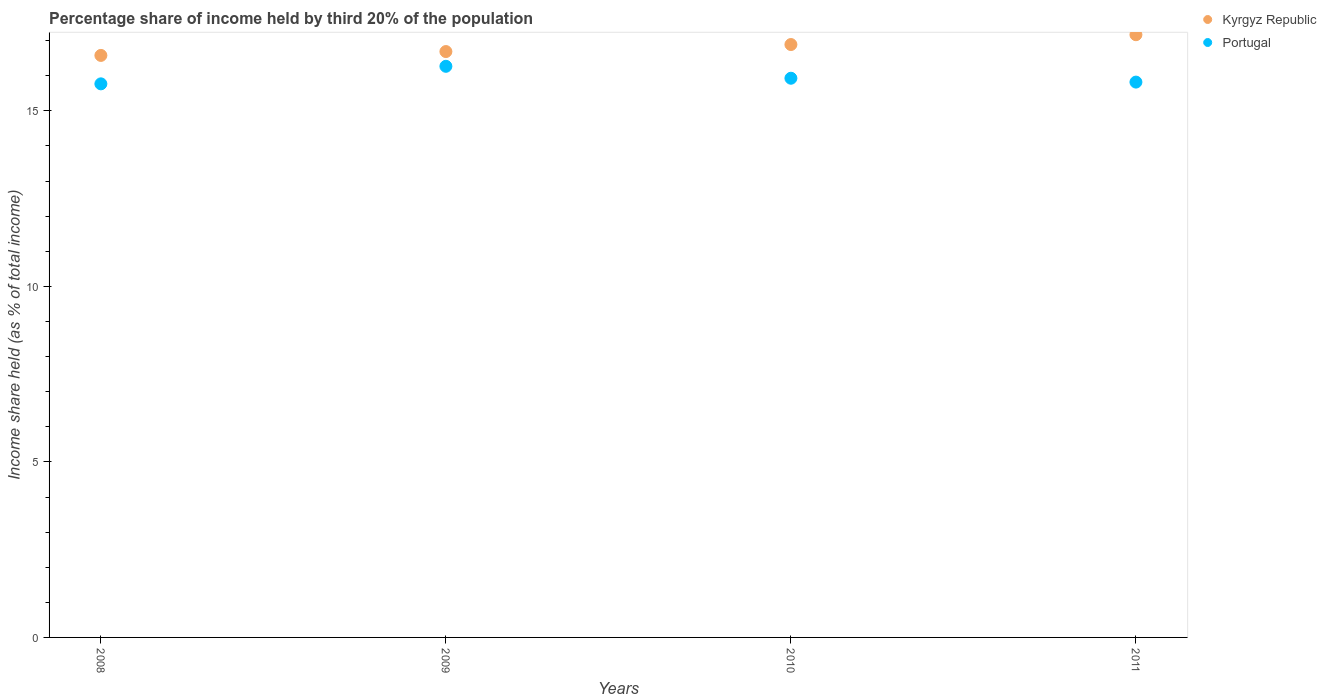How many different coloured dotlines are there?
Ensure brevity in your answer.  2. Is the number of dotlines equal to the number of legend labels?
Ensure brevity in your answer.  Yes. What is the share of income held by third 20% of the population in Kyrgyz Republic in 2009?
Make the answer very short. 16.69. Across all years, what is the maximum share of income held by third 20% of the population in Kyrgyz Republic?
Give a very brief answer. 17.17. Across all years, what is the minimum share of income held by third 20% of the population in Kyrgyz Republic?
Provide a succinct answer. 16.58. In which year was the share of income held by third 20% of the population in Portugal maximum?
Offer a terse response. 2009. What is the total share of income held by third 20% of the population in Portugal in the graph?
Offer a very short reply. 63.79. What is the difference between the share of income held by third 20% of the population in Portugal in 2008 and that in 2011?
Keep it short and to the point. -0.05. What is the difference between the share of income held by third 20% of the population in Portugal in 2010 and the share of income held by third 20% of the population in Kyrgyz Republic in 2009?
Offer a very short reply. -0.76. What is the average share of income held by third 20% of the population in Portugal per year?
Provide a succinct answer. 15.95. In the year 2011, what is the difference between the share of income held by third 20% of the population in Kyrgyz Republic and share of income held by third 20% of the population in Portugal?
Provide a succinct answer. 1.35. What is the ratio of the share of income held by third 20% of the population in Kyrgyz Republic in 2008 to that in 2009?
Provide a short and direct response. 0.99. Is the difference between the share of income held by third 20% of the population in Kyrgyz Republic in 2008 and 2011 greater than the difference between the share of income held by third 20% of the population in Portugal in 2008 and 2011?
Offer a terse response. No. What is the difference between the highest and the second highest share of income held by third 20% of the population in Portugal?
Your answer should be compact. 0.34. What is the difference between the highest and the lowest share of income held by third 20% of the population in Kyrgyz Republic?
Offer a very short reply. 0.59. In how many years, is the share of income held by third 20% of the population in Portugal greater than the average share of income held by third 20% of the population in Portugal taken over all years?
Your response must be concise. 1. Is the sum of the share of income held by third 20% of the population in Portugal in 2009 and 2011 greater than the maximum share of income held by third 20% of the population in Kyrgyz Republic across all years?
Ensure brevity in your answer.  Yes. Does the share of income held by third 20% of the population in Kyrgyz Republic monotonically increase over the years?
Provide a short and direct response. Yes. Is the share of income held by third 20% of the population in Portugal strictly greater than the share of income held by third 20% of the population in Kyrgyz Republic over the years?
Your answer should be very brief. No. Is the share of income held by third 20% of the population in Kyrgyz Republic strictly less than the share of income held by third 20% of the population in Portugal over the years?
Give a very brief answer. No. How many years are there in the graph?
Provide a succinct answer. 4. What is the difference between two consecutive major ticks on the Y-axis?
Give a very brief answer. 5. Does the graph contain any zero values?
Your response must be concise. No. Does the graph contain grids?
Make the answer very short. No. Where does the legend appear in the graph?
Provide a succinct answer. Top right. What is the title of the graph?
Offer a terse response. Percentage share of income held by third 20% of the population. What is the label or title of the X-axis?
Offer a very short reply. Years. What is the label or title of the Y-axis?
Your response must be concise. Income share held (as % of total income). What is the Income share held (as % of total income) of Kyrgyz Republic in 2008?
Ensure brevity in your answer.  16.58. What is the Income share held (as % of total income) of Portugal in 2008?
Your answer should be compact. 15.77. What is the Income share held (as % of total income) in Kyrgyz Republic in 2009?
Provide a short and direct response. 16.69. What is the Income share held (as % of total income) of Portugal in 2009?
Provide a succinct answer. 16.27. What is the Income share held (as % of total income) in Kyrgyz Republic in 2010?
Make the answer very short. 16.89. What is the Income share held (as % of total income) of Portugal in 2010?
Offer a terse response. 15.93. What is the Income share held (as % of total income) of Kyrgyz Republic in 2011?
Provide a succinct answer. 17.17. What is the Income share held (as % of total income) in Portugal in 2011?
Your answer should be compact. 15.82. Across all years, what is the maximum Income share held (as % of total income) in Kyrgyz Republic?
Make the answer very short. 17.17. Across all years, what is the maximum Income share held (as % of total income) in Portugal?
Your answer should be very brief. 16.27. Across all years, what is the minimum Income share held (as % of total income) of Kyrgyz Republic?
Ensure brevity in your answer.  16.58. Across all years, what is the minimum Income share held (as % of total income) in Portugal?
Ensure brevity in your answer.  15.77. What is the total Income share held (as % of total income) of Kyrgyz Republic in the graph?
Give a very brief answer. 67.33. What is the total Income share held (as % of total income) in Portugal in the graph?
Ensure brevity in your answer.  63.79. What is the difference between the Income share held (as % of total income) in Kyrgyz Republic in 2008 and that in 2009?
Your response must be concise. -0.11. What is the difference between the Income share held (as % of total income) of Kyrgyz Republic in 2008 and that in 2010?
Provide a short and direct response. -0.31. What is the difference between the Income share held (as % of total income) of Portugal in 2008 and that in 2010?
Offer a terse response. -0.16. What is the difference between the Income share held (as % of total income) in Kyrgyz Republic in 2008 and that in 2011?
Your answer should be very brief. -0.59. What is the difference between the Income share held (as % of total income) of Kyrgyz Republic in 2009 and that in 2010?
Your answer should be very brief. -0.2. What is the difference between the Income share held (as % of total income) in Portugal in 2009 and that in 2010?
Offer a terse response. 0.34. What is the difference between the Income share held (as % of total income) in Kyrgyz Republic in 2009 and that in 2011?
Offer a very short reply. -0.48. What is the difference between the Income share held (as % of total income) in Portugal in 2009 and that in 2011?
Provide a succinct answer. 0.45. What is the difference between the Income share held (as % of total income) in Kyrgyz Republic in 2010 and that in 2011?
Your answer should be compact. -0.28. What is the difference between the Income share held (as % of total income) in Portugal in 2010 and that in 2011?
Give a very brief answer. 0.11. What is the difference between the Income share held (as % of total income) in Kyrgyz Republic in 2008 and the Income share held (as % of total income) in Portugal in 2009?
Give a very brief answer. 0.31. What is the difference between the Income share held (as % of total income) in Kyrgyz Republic in 2008 and the Income share held (as % of total income) in Portugal in 2010?
Keep it short and to the point. 0.65. What is the difference between the Income share held (as % of total income) of Kyrgyz Republic in 2008 and the Income share held (as % of total income) of Portugal in 2011?
Your response must be concise. 0.76. What is the difference between the Income share held (as % of total income) of Kyrgyz Republic in 2009 and the Income share held (as % of total income) of Portugal in 2010?
Offer a very short reply. 0.76. What is the difference between the Income share held (as % of total income) in Kyrgyz Republic in 2009 and the Income share held (as % of total income) in Portugal in 2011?
Offer a very short reply. 0.87. What is the difference between the Income share held (as % of total income) of Kyrgyz Republic in 2010 and the Income share held (as % of total income) of Portugal in 2011?
Offer a terse response. 1.07. What is the average Income share held (as % of total income) in Kyrgyz Republic per year?
Your response must be concise. 16.83. What is the average Income share held (as % of total income) of Portugal per year?
Your answer should be very brief. 15.95. In the year 2008, what is the difference between the Income share held (as % of total income) of Kyrgyz Republic and Income share held (as % of total income) of Portugal?
Provide a succinct answer. 0.81. In the year 2009, what is the difference between the Income share held (as % of total income) in Kyrgyz Republic and Income share held (as % of total income) in Portugal?
Keep it short and to the point. 0.42. In the year 2011, what is the difference between the Income share held (as % of total income) of Kyrgyz Republic and Income share held (as % of total income) of Portugal?
Provide a short and direct response. 1.35. What is the ratio of the Income share held (as % of total income) in Portugal in 2008 to that in 2009?
Provide a short and direct response. 0.97. What is the ratio of the Income share held (as % of total income) in Kyrgyz Republic in 2008 to that in 2010?
Offer a very short reply. 0.98. What is the ratio of the Income share held (as % of total income) in Kyrgyz Republic in 2008 to that in 2011?
Give a very brief answer. 0.97. What is the ratio of the Income share held (as % of total income) of Portugal in 2008 to that in 2011?
Ensure brevity in your answer.  1. What is the ratio of the Income share held (as % of total income) in Portugal in 2009 to that in 2010?
Your answer should be compact. 1.02. What is the ratio of the Income share held (as % of total income) of Kyrgyz Republic in 2009 to that in 2011?
Your response must be concise. 0.97. What is the ratio of the Income share held (as % of total income) of Portugal in 2009 to that in 2011?
Keep it short and to the point. 1.03. What is the ratio of the Income share held (as % of total income) in Kyrgyz Republic in 2010 to that in 2011?
Provide a succinct answer. 0.98. What is the difference between the highest and the second highest Income share held (as % of total income) in Kyrgyz Republic?
Keep it short and to the point. 0.28. What is the difference between the highest and the second highest Income share held (as % of total income) in Portugal?
Make the answer very short. 0.34. What is the difference between the highest and the lowest Income share held (as % of total income) in Kyrgyz Republic?
Your answer should be very brief. 0.59. 